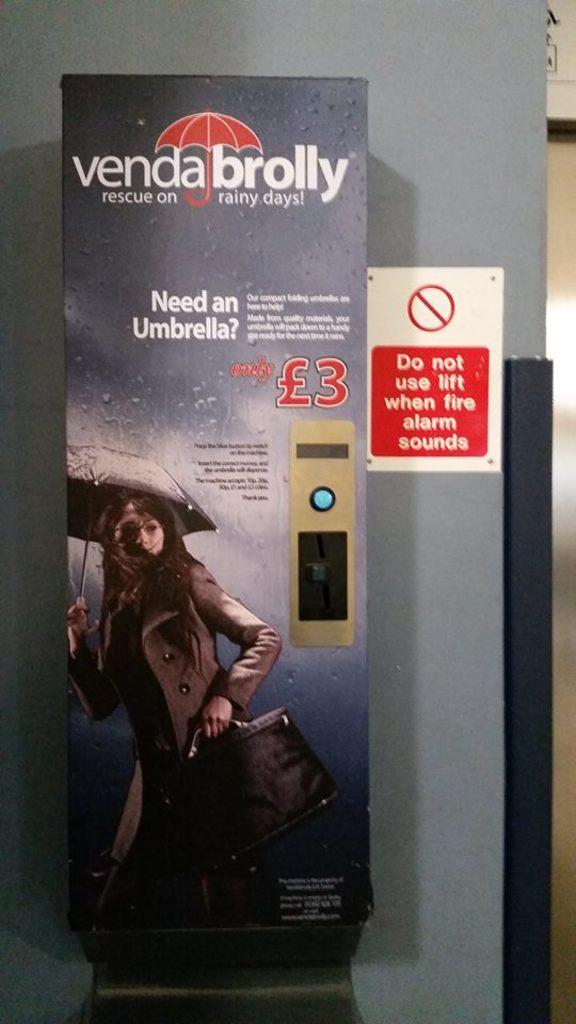Can you describe this image briefly? In this image we can see an advertisement and board on the wall. 